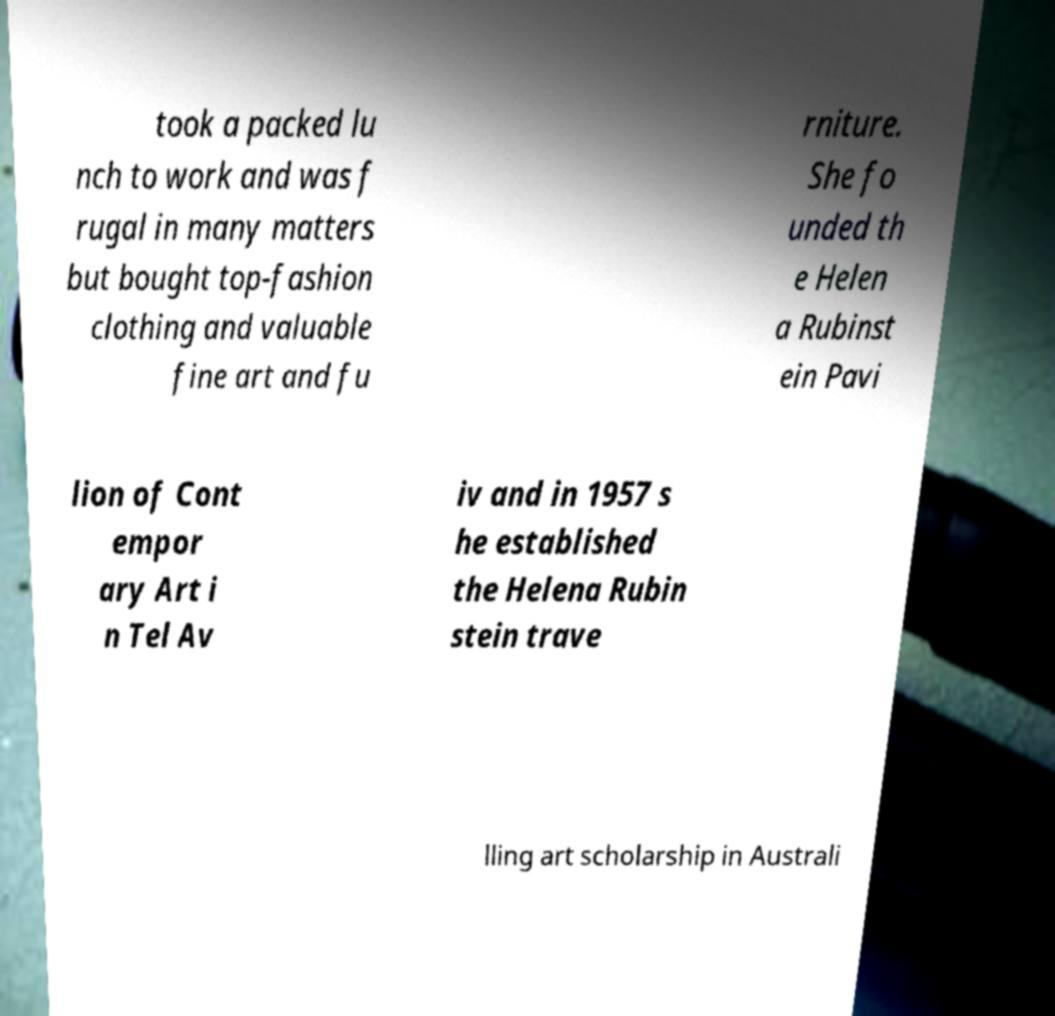Could you extract and type out the text from this image? took a packed lu nch to work and was f rugal in many matters but bought top-fashion clothing and valuable fine art and fu rniture. She fo unded th e Helen a Rubinst ein Pavi lion of Cont empor ary Art i n Tel Av iv and in 1957 s he established the Helena Rubin stein trave lling art scholarship in Australi 